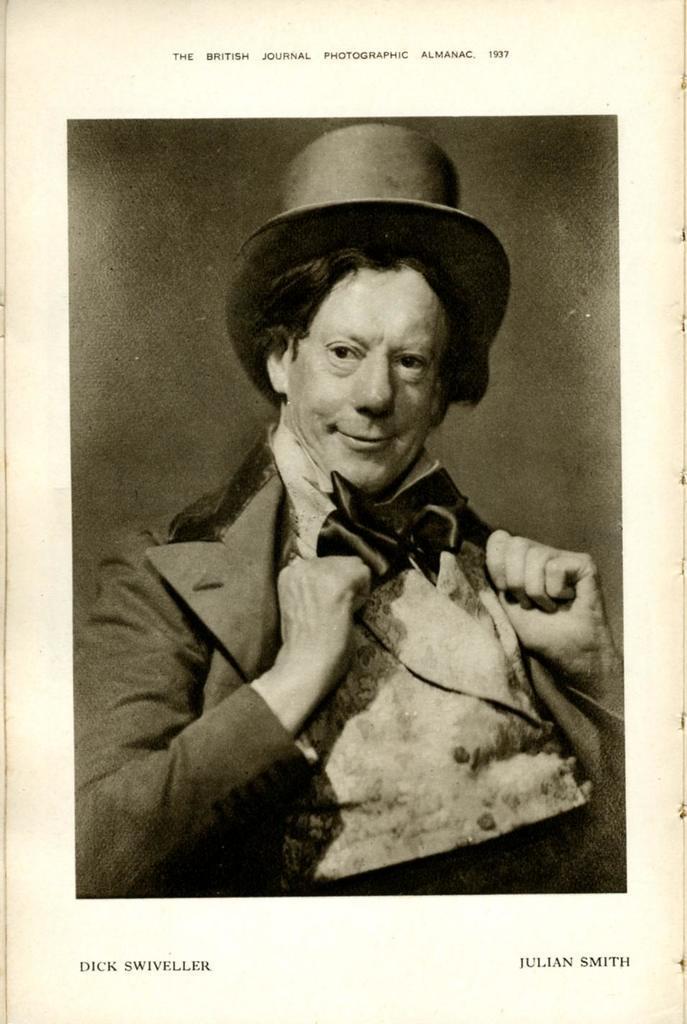Could you give a brief overview of what you see in this image? This is the image of the page of a book where there is a picture of a person and some text. 